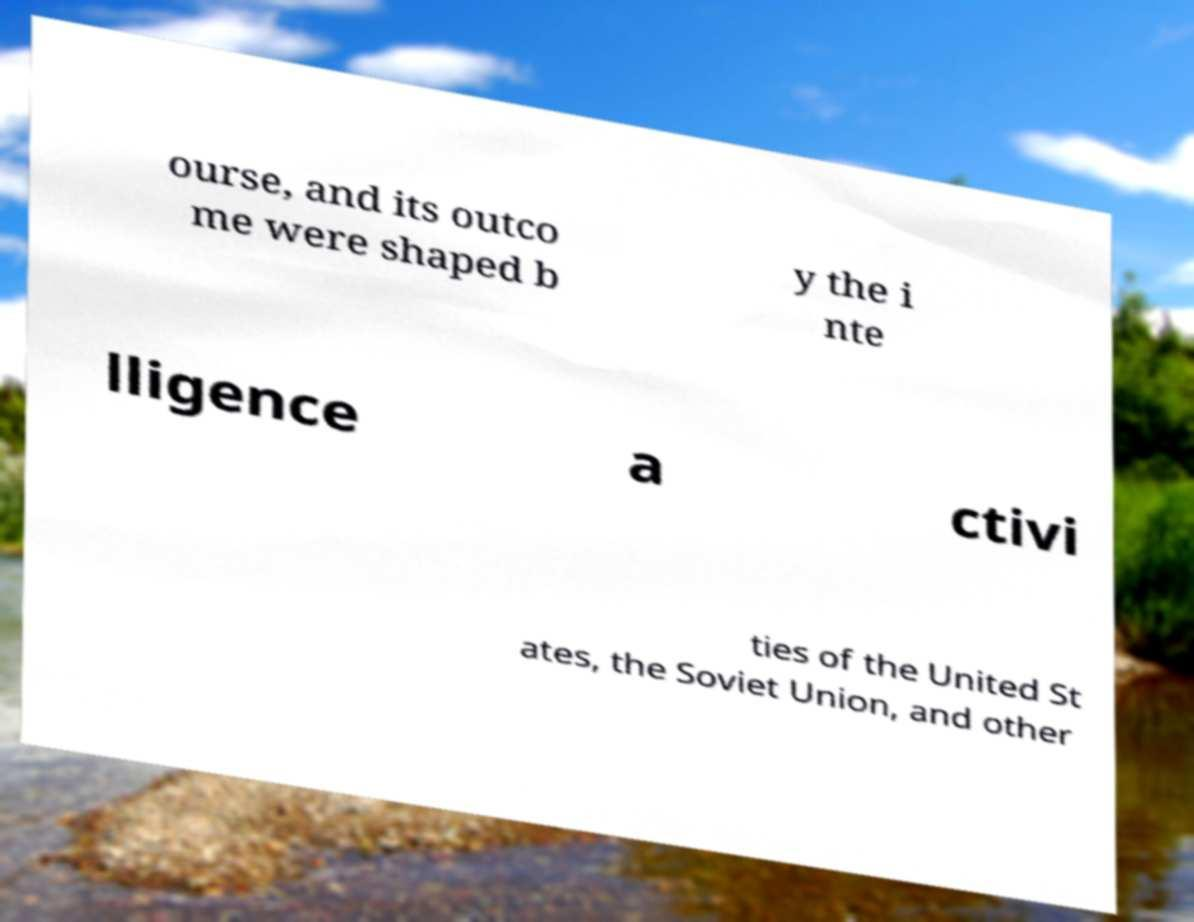There's text embedded in this image that I need extracted. Can you transcribe it verbatim? ourse, and its outco me were shaped b y the i nte lligence a ctivi ties of the United St ates, the Soviet Union, and other 